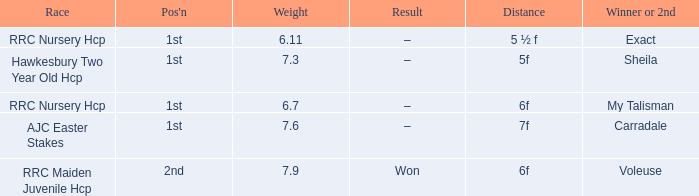What is the weight number when the distance was 5 ½ f? 1.0. 